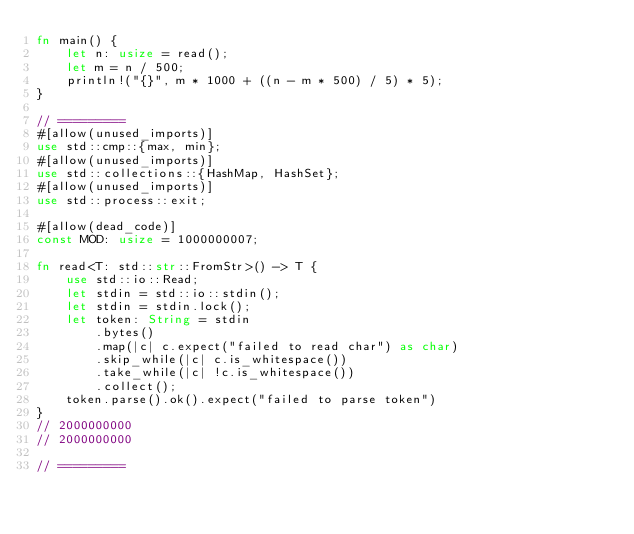<code> <loc_0><loc_0><loc_500><loc_500><_Rust_>fn main() {
    let n: usize = read();
    let m = n / 500;
    println!("{}", m * 1000 + ((n - m * 500) / 5) * 5);
}

// =========
#[allow(unused_imports)]
use std::cmp::{max, min};
#[allow(unused_imports)]
use std::collections::{HashMap, HashSet};
#[allow(unused_imports)]
use std::process::exit;

#[allow(dead_code)]
const MOD: usize = 1000000007;

fn read<T: std::str::FromStr>() -> T {
    use std::io::Read;
    let stdin = std::io::stdin();
    let stdin = stdin.lock();
    let token: String = stdin
        .bytes()
        .map(|c| c.expect("failed to read char") as char)
        .skip_while(|c| c.is_whitespace())
        .take_while(|c| !c.is_whitespace())
        .collect();
    token.parse().ok().expect("failed to parse token")
}
// 2000000000
// 2000000000

// =========
</code> 